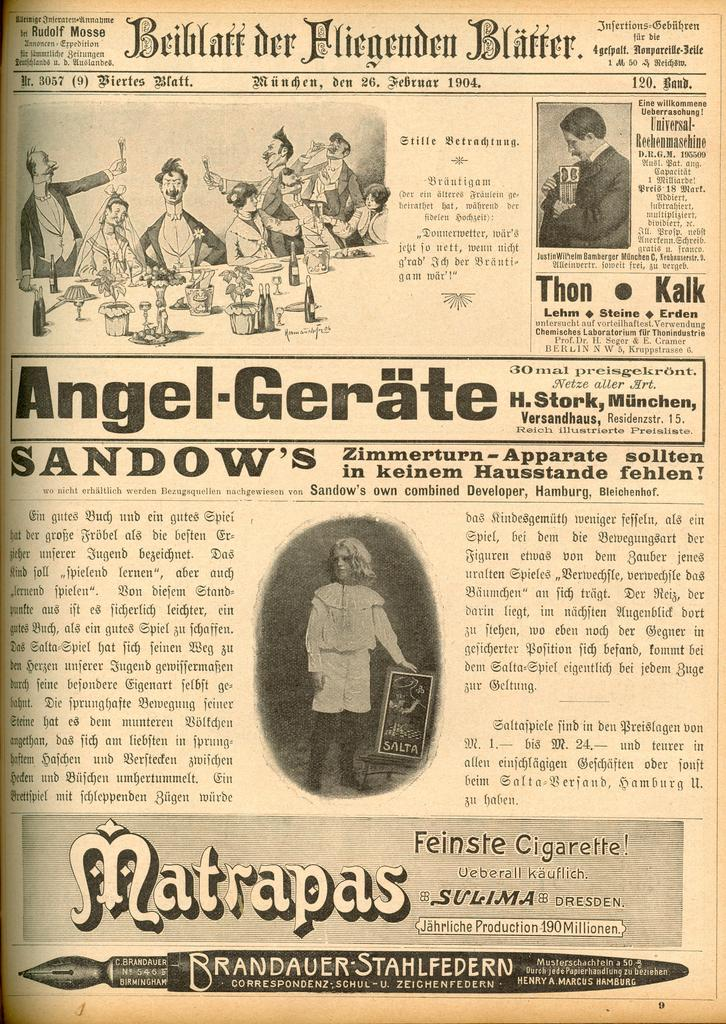What type of visual is the image? The image is a poster. Who or what can be seen on the poster? There are people depicted on the poster. What else is shown on the poster besides people? There are bottles and other objects depicted on the poster. Is there any written information on the poster? Yes, there is text present on the poster. Can you see any trucks emitting smoke in the image? No, there are no trucks or smoke present in the image. Are there any chickens depicted on the poster? No, there are no chickens depicted on the poster. 